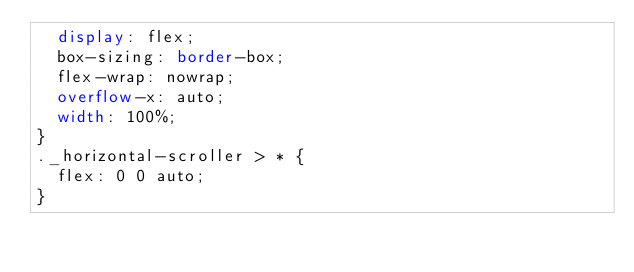Convert code to text. <code><loc_0><loc_0><loc_500><loc_500><_CSS_>  display: flex;
  box-sizing: border-box;
  flex-wrap: nowrap;
  overflow-x: auto;
  width: 100%;
}
._horizontal-scroller > * {
  flex: 0 0 auto;
}
</code> 